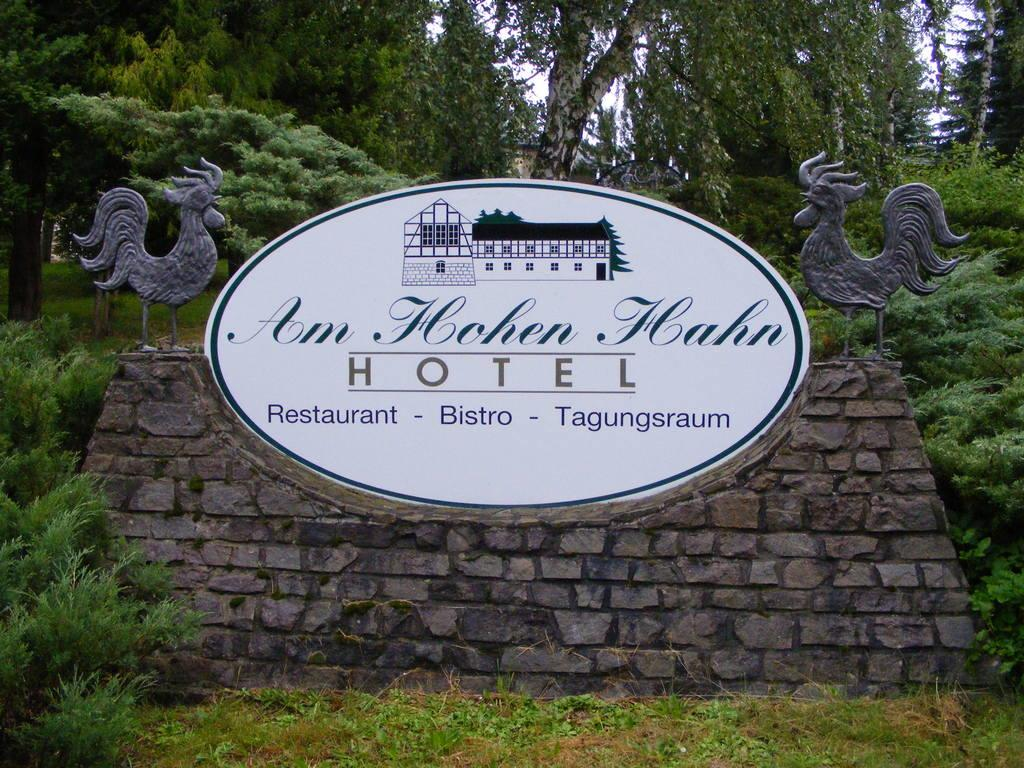What type of vegetation is present in the image? There are many trees and few plants in the image. What object in the image has text on it? There is a board in the image with text on it. What kind of artwork is featured in the image? There is a sculpture of birds in the image. How does the wind affect the wave in the image? There is no wave present in the image, as it only features trees, plants, a board, and a sculpture of birds. 